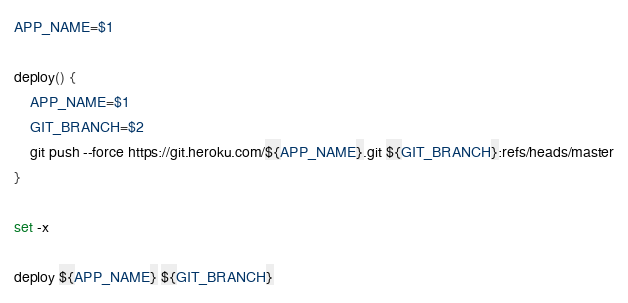Convert code to text. <code><loc_0><loc_0><loc_500><loc_500><_Bash_>APP_NAME=$1

deploy() {
    APP_NAME=$1
    GIT_BRANCH=$2
    git push --force https://git.heroku.com/${APP_NAME}.git ${GIT_BRANCH}:refs/heads/master
}

set -x

deploy ${APP_NAME} ${GIT_BRANCH}
</code> 